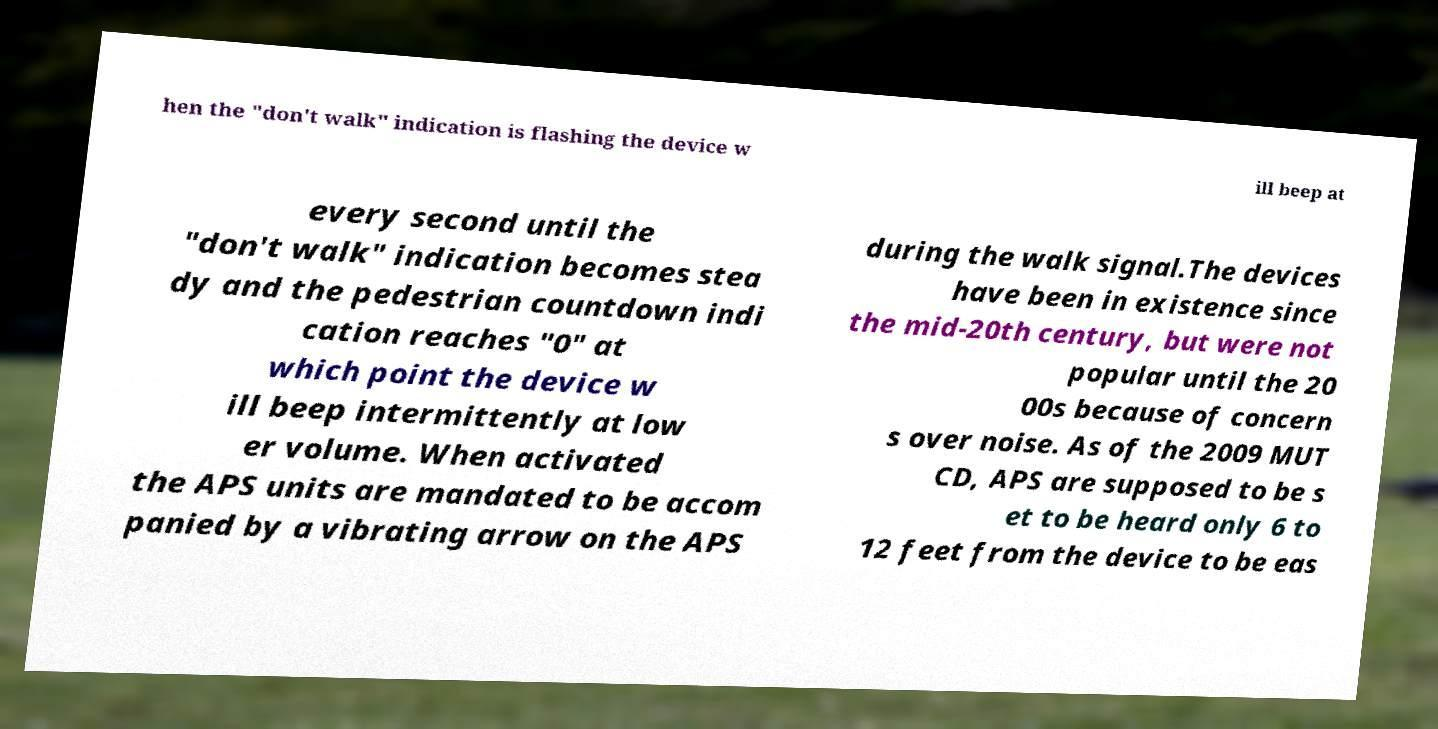Please read and relay the text visible in this image. What does it say? hen the "don't walk" indication is flashing the device w ill beep at every second until the "don't walk" indication becomes stea dy and the pedestrian countdown indi cation reaches "0" at which point the device w ill beep intermittently at low er volume. When activated the APS units are mandated to be accom panied by a vibrating arrow on the APS during the walk signal.The devices have been in existence since the mid-20th century, but were not popular until the 20 00s because of concern s over noise. As of the 2009 MUT CD, APS are supposed to be s et to be heard only 6 to 12 feet from the device to be eas 